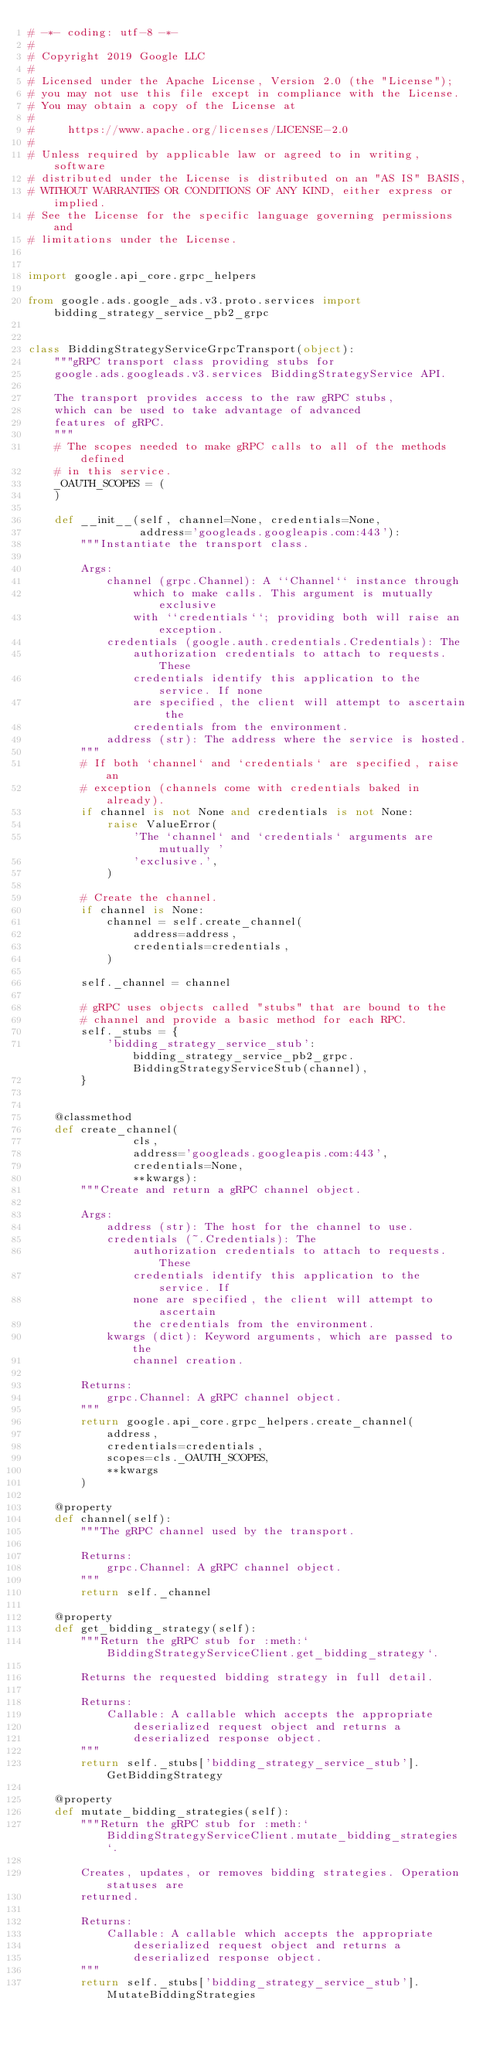<code> <loc_0><loc_0><loc_500><loc_500><_Python_># -*- coding: utf-8 -*-
#
# Copyright 2019 Google LLC
#
# Licensed under the Apache License, Version 2.0 (the "License");
# you may not use this file except in compliance with the License.
# You may obtain a copy of the License at
#
#     https://www.apache.org/licenses/LICENSE-2.0
#
# Unless required by applicable law or agreed to in writing, software
# distributed under the License is distributed on an "AS IS" BASIS,
# WITHOUT WARRANTIES OR CONDITIONS OF ANY KIND, either express or implied.
# See the License for the specific language governing permissions and
# limitations under the License.


import google.api_core.grpc_helpers

from google.ads.google_ads.v3.proto.services import bidding_strategy_service_pb2_grpc


class BiddingStrategyServiceGrpcTransport(object):
    """gRPC transport class providing stubs for
    google.ads.googleads.v3.services BiddingStrategyService API.

    The transport provides access to the raw gRPC stubs,
    which can be used to take advantage of advanced
    features of gRPC.
    """
    # The scopes needed to make gRPC calls to all of the methods defined
    # in this service.
    _OAUTH_SCOPES = (
    )

    def __init__(self, channel=None, credentials=None,
                 address='googleads.googleapis.com:443'):
        """Instantiate the transport class.

        Args:
            channel (grpc.Channel): A ``Channel`` instance through
                which to make calls. This argument is mutually exclusive
                with ``credentials``; providing both will raise an exception.
            credentials (google.auth.credentials.Credentials): The
                authorization credentials to attach to requests. These
                credentials identify this application to the service. If none
                are specified, the client will attempt to ascertain the
                credentials from the environment.
            address (str): The address where the service is hosted.
        """
        # If both `channel` and `credentials` are specified, raise an
        # exception (channels come with credentials baked in already).
        if channel is not None and credentials is not None:
            raise ValueError(
                'The `channel` and `credentials` arguments are mutually '
                'exclusive.',
            )

        # Create the channel.
        if channel is None:
            channel = self.create_channel(
                address=address,
                credentials=credentials,
            )

        self._channel = channel

        # gRPC uses objects called "stubs" that are bound to the
        # channel and provide a basic method for each RPC.
        self._stubs = {
            'bidding_strategy_service_stub': bidding_strategy_service_pb2_grpc.BiddingStrategyServiceStub(channel),
        }


    @classmethod
    def create_channel(
                cls,
                address='googleads.googleapis.com:443',
                credentials=None,
                **kwargs):
        """Create and return a gRPC channel object.

        Args:
            address (str): The host for the channel to use.
            credentials (~.Credentials): The
                authorization credentials to attach to requests. These
                credentials identify this application to the service. If
                none are specified, the client will attempt to ascertain
                the credentials from the environment.
            kwargs (dict): Keyword arguments, which are passed to the
                channel creation.

        Returns:
            grpc.Channel: A gRPC channel object.
        """
        return google.api_core.grpc_helpers.create_channel(
            address,
            credentials=credentials,
            scopes=cls._OAUTH_SCOPES,
            **kwargs
        )

    @property
    def channel(self):
        """The gRPC channel used by the transport.

        Returns:
            grpc.Channel: A gRPC channel object.
        """
        return self._channel

    @property
    def get_bidding_strategy(self):
        """Return the gRPC stub for :meth:`BiddingStrategyServiceClient.get_bidding_strategy`.

        Returns the requested bidding strategy in full detail.

        Returns:
            Callable: A callable which accepts the appropriate
                deserialized request object and returns a
                deserialized response object.
        """
        return self._stubs['bidding_strategy_service_stub'].GetBiddingStrategy

    @property
    def mutate_bidding_strategies(self):
        """Return the gRPC stub for :meth:`BiddingStrategyServiceClient.mutate_bidding_strategies`.

        Creates, updates, or removes bidding strategies. Operation statuses are
        returned.

        Returns:
            Callable: A callable which accepts the appropriate
                deserialized request object and returns a
                deserialized response object.
        """
        return self._stubs['bidding_strategy_service_stub'].MutateBiddingStrategies</code> 